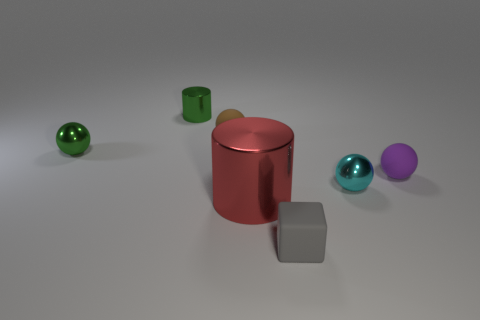Is the shape of the tiny purple object the same as the large red shiny object?
Make the answer very short. No. What size is the shiny ball on the right side of the tiny matte object in front of the big red cylinder?
Keep it short and to the point. Small. Are there any brown spheres of the same size as the gray object?
Offer a very short reply. Yes. Does the matte object behind the green ball have the same size as the cylinder behind the tiny purple matte sphere?
Your answer should be very brief. Yes. There is a rubber object behind the small green thing to the left of the small cylinder; what is its shape?
Provide a succinct answer. Sphere. There is a small rubber block; what number of tiny green metallic cylinders are in front of it?
Provide a succinct answer. 0. The other sphere that is the same material as the cyan ball is what color?
Ensure brevity in your answer.  Green. There is a matte cube; is it the same size as the rubber thing that is on the left side of the tiny cube?
Keep it short and to the point. Yes. There is a metallic sphere that is left of the small brown rubber thing to the left of the rubber ball to the right of the block; how big is it?
Offer a very short reply. Small. How many metal objects are gray things or small red blocks?
Ensure brevity in your answer.  0. 